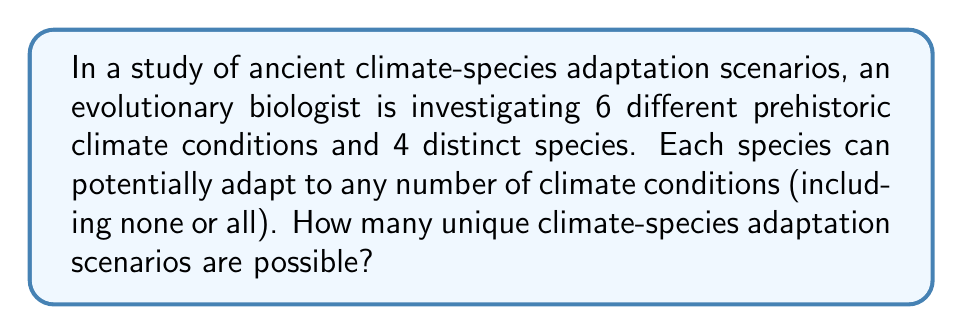What is the answer to this math problem? To solve this problem, we need to follow these steps:

1) For each species, we need to determine how many ways it can adapt to the climate conditions.

2) Each species has two options for each climate condition: adapt or not adapt. This creates a binary choice for each of the 6 climate conditions.

3) The number of possible adaptation scenarios for each species is therefore $2^6$, as there are 2 choices for each of the 6 climate conditions.

4) Since there are 4 distinct species, and each species can independently adapt in $2^6$ ways, we need to apply the multiplication principle.

5) The total number of unique scenarios is thus $(2^6)^4$.

Let's calculate:

$$(2^6)^4 = 64^4 = 16,777,216$$

This can also be written as:

$$2^{6 \times 4} = 2^{24} = 16,777,216$$

This large number represents all possible combinations of adaptations across the 4 species and 6 climate conditions.
Answer: $16,777,216$ 